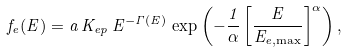<formula> <loc_0><loc_0><loc_500><loc_500>f _ { e } ( E ) = a \, K _ { e p } \, E ^ { - \Gamma ( E ) } \, \exp \left ( - \frac { 1 } { \alpha } \left [ \frac { E } { E _ { e , \max } } \right ] ^ { \alpha } \right ) ,</formula> 